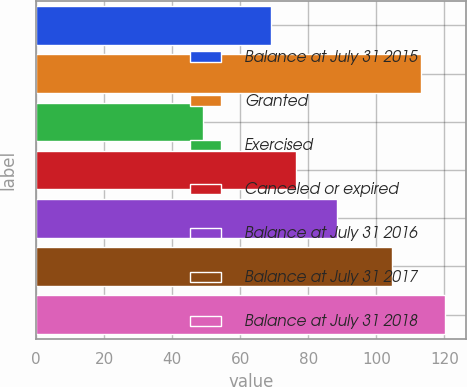Convert chart. <chart><loc_0><loc_0><loc_500><loc_500><bar_chart><fcel>Balance at July 31 2015<fcel>Granted<fcel>Exercised<fcel>Canceled or expired<fcel>Balance at July 31 2016<fcel>Balance at July 31 2017<fcel>Balance at July 31 2018<nl><fcel>69.13<fcel>113.08<fcel>48.93<fcel>76.26<fcel>88.55<fcel>104.5<fcel>120.26<nl></chart> 